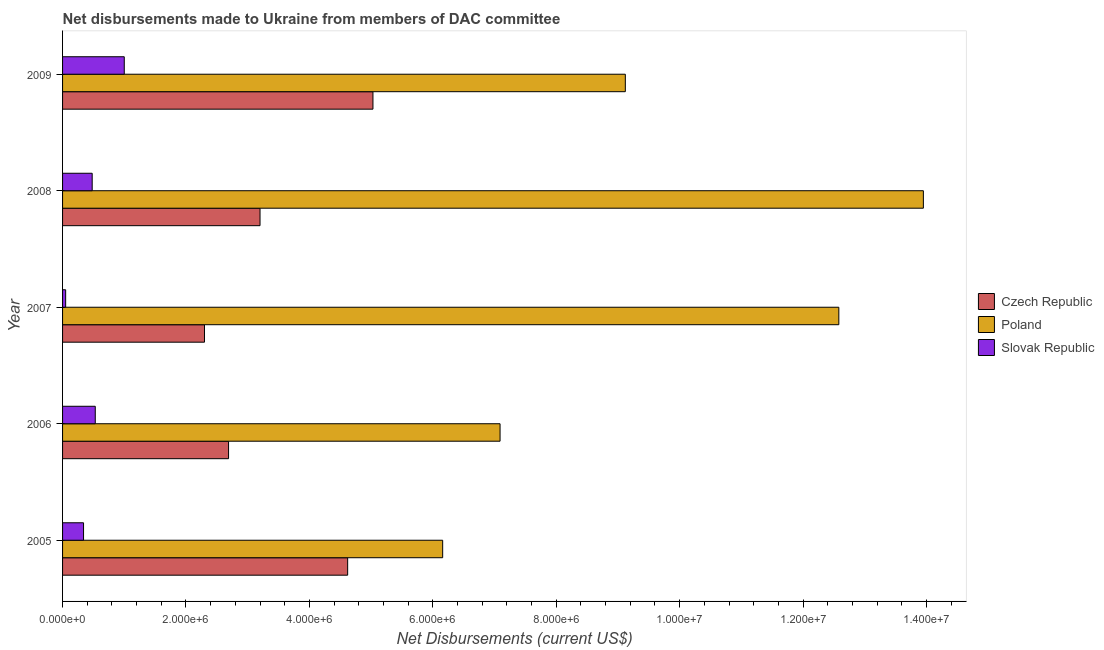Are the number of bars per tick equal to the number of legend labels?
Make the answer very short. Yes. Are the number of bars on each tick of the Y-axis equal?
Give a very brief answer. Yes. What is the label of the 5th group of bars from the top?
Your response must be concise. 2005. In how many cases, is the number of bars for a given year not equal to the number of legend labels?
Keep it short and to the point. 0. What is the net disbursements made by slovak republic in 2008?
Your response must be concise. 4.80e+05. Across all years, what is the maximum net disbursements made by slovak republic?
Offer a very short reply. 1.00e+06. Across all years, what is the minimum net disbursements made by slovak republic?
Make the answer very short. 5.00e+04. In which year was the net disbursements made by poland minimum?
Provide a short and direct response. 2005. What is the total net disbursements made by czech republic in the graph?
Provide a succinct answer. 1.78e+07. What is the difference between the net disbursements made by poland in 2005 and that in 2009?
Provide a short and direct response. -2.96e+06. What is the difference between the net disbursements made by czech republic in 2009 and the net disbursements made by poland in 2005?
Offer a terse response. -1.13e+06. What is the average net disbursements made by slovak republic per year?
Provide a short and direct response. 4.80e+05. In the year 2009, what is the difference between the net disbursements made by slovak republic and net disbursements made by czech republic?
Your answer should be very brief. -4.03e+06. In how many years, is the net disbursements made by czech republic greater than 7600000 US$?
Provide a short and direct response. 0. What is the ratio of the net disbursements made by czech republic in 2006 to that in 2009?
Ensure brevity in your answer.  0.54. Is the difference between the net disbursements made by slovak republic in 2006 and 2009 greater than the difference between the net disbursements made by poland in 2006 and 2009?
Your answer should be compact. Yes. What is the difference between the highest and the second highest net disbursements made by czech republic?
Give a very brief answer. 4.10e+05. What is the difference between the highest and the lowest net disbursements made by slovak republic?
Ensure brevity in your answer.  9.50e+05. What does the 3rd bar from the top in 2005 represents?
Your response must be concise. Czech Republic. What does the 2nd bar from the bottom in 2005 represents?
Your answer should be very brief. Poland. Are all the bars in the graph horizontal?
Ensure brevity in your answer.  Yes. How many years are there in the graph?
Your answer should be compact. 5. What is the difference between two consecutive major ticks on the X-axis?
Provide a short and direct response. 2.00e+06. Are the values on the major ticks of X-axis written in scientific E-notation?
Give a very brief answer. Yes. Does the graph contain any zero values?
Offer a terse response. No. Does the graph contain grids?
Keep it short and to the point. No. How many legend labels are there?
Provide a succinct answer. 3. How are the legend labels stacked?
Your response must be concise. Vertical. What is the title of the graph?
Make the answer very short. Net disbursements made to Ukraine from members of DAC committee. Does "Ages 20-60" appear as one of the legend labels in the graph?
Give a very brief answer. No. What is the label or title of the X-axis?
Provide a short and direct response. Net Disbursements (current US$). What is the Net Disbursements (current US$) of Czech Republic in 2005?
Offer a very short reply. 4.62e+06. What is the Net Disbursements (current US$) in Poland in 2005?
Your response must be concise. 6.16e+06. What is the Net Disbursements (current US$) of Czech Republic in 2006?
Keep it short and to the point. 2.69e+06. What is the Net Disbursements (current US$) in Poland in 2006?
Provide a succinct answer. 7.09e+06. What is the Net Disbursements (current US$) in Slovak Republic in 2006?
Make the answer very short. 5.30e+05. What is the Net Disbursements (current US$) of Czech Republic in 2007?
Provide a succinct answer. 2.30e+06. What is the Net Disbursements (current US$) of Poland in 2007?
Provide a succinct answer. 1.26e+07. What is the Net Disbursements (current US$) in Czech Republic in 2008?
Give a very brief answer. 3.20e+06. What is the Net Disbursements (current US$) of Poland in 2008?
Your response must be concise. 1.40e+07. What is the Net Disbursements (current US$) in Slovak Republic in 2008?
Provide a succinct answer. 4.80e+05. What is the Net Disbursements (current US$) of Czech Republic in 2009?
Ensure brevity in your answer.  5.03e+06. What is the Net Disbursements (current US$) in Poland in 2009?
Offer a terse response. 9.12e+06. Across all years, what is the maximum Net Disbursements (current US$) of Czech Republic?
Your answer should be compact. 5.03e+06. Across all years, what is the maximum Net Disbursements (current US$) of Poland?
Your response must be concise. 1.40e+07. Across all years, what is the maximum Net Disbursements (current US$) in Slovak Republic?
Give a very brief answer. 1.00e+06. Across all years, what is the minimum Net Disbursements (current US$) of Czech Republic?
Keep it short and to the point. 2.30e+06. Across all years, what is the minimum Net Disbursements (current US$) of Poland?
Offer a very short reply. 6.16e+06. Across all years, what is the minimum Net Disbursements (current US$) of Slovak Republic?
Ensure brevity in your answer.  5.00e+04. What is the total Net Disbursements (current US$) in Czech Republic in the graph?
Your response must be concise. 1.78e+07. What is the total Net Disbursements (current US$) in Poland in the graph?
Offer a terse response. 4.89e+07. What is the total Net Disbursements (current US$) in Slovak Republic in the graph?
Your answer should be compact. 2.40e+06. What is the difference between the Net Disbursements (current US$) of Czech Republic in 2005 and that in 2006?
Offer a very short reply. 1.93e+06. What is the difference between the Net Disbursements (current US$) of Poland in 2005 and that in 2006?
Your response must be concise. -9.30e+05. What is the difference between the Net Disbursements (current US$) in Slovak Republic in 2005 and that in 2006?
Give a very brief answer. -1.90e+05. What is the difference between the Net Disbursements (current US$) of Czech Republic in 2005 and that in 2007?
Your answer should be compact. 2.32e+06. What is the difference between the Net Disbursements (current US$) of Poland in 2005 and that in 2007?
Keep it short and to the point. -6.42e+06. What is the difference between the Net Disbursements (current US$) in Czech Republic in 2005 and that in 2008?
Ensure brevity in your answer.  1.42e+06. What is the difference between the Net Disbursements (current US$) in Poland in 2005 and that in 2008?
Ensure brevity in your answer.  -7.79e+06. What is the difference between the Net Disbursements (current US$) in Slovak Republic in 2005 and that in 2008?
Keep it short and to the point. -1.40e+05. What is the difference between the Net Disbursements (current US$) of Czech Republic in 2005 and that in 2009?
Offer a terse response. -4.10e+05. What is the difference between the Net Disbursements (current US$) of Poland in 2005 and that in 2009?
Keep it short and to the point. -2.96e+06. What is the difference between the Net Disbursements (current US$) of Slovak Republic in 2005 and that in 2009?
Your answer should be compact. -6.60e+05. What is the difference between the Net Disbursements (current US$) of Poland in 2006 and that in 2007?
Provide a succinct answer. -5.49e+06. What is the difference between the Net Disbursements (current US$) of Slovak Republic in 2006 and that in 2007?
Provide a succinct answer. 4.80e+05. What is the difference between the Net Disbursements (current US$) in Czech Republic in 2006 and that in 2008?
Ensure brevity in your answer.  -5.10e+05. What is the difference between the Net Disbursements (current US$) in Poland in 2006 and that in 2008?
Your answer should be very brief. -6.86e+06. What is the difference between the Net Disbursements (current US$) of Slovak Republic in 2006 and that in 2008?
Keep it short and to the point. 5.00e+04. What is the difference between the Net Disbursements (current US$) in Czech Republic in 2006 and that in 2009?
Make the answer very short. -2.34e+06. What is the difference between the Net Disbursements (current US$) in Poland in 2006 and that in 2009?
Your answer should be very brief. -2.03e+06. What is the difference between the Net Disbursements (current US$) in Slovak Republic in 2006 and that in 2009?
Provide a short and direct response. -4.70e+05. What is the difference between the Net Disbursements (current US$) in Czech Republic in 2007 and that in 2008?
Ensure brevity in your answer.  -9.00e+05. What is the difference between the Net Disbursements (current US$) of Poland in 2007 and that in 2008?
Provide a short and direct response. -1.37e+06. What is the difference between the Net Disbursements (current US$) in Slovak Republic in 2007 and that in 2008?
Make the answer very short. -4.30e+05. What is the difference between the Net Disbursements (current US$) of Czech Republic in 2007 and that in 2009?
Provide a short and direct response. -2.73e+06. What is the difference between the Net Disbursements (current US$) of Poland in 2007 and that in 2009?
Your response must be concise. 3.46e+06. What is the difference between the Net Disbursements (current US$) of Slovak Republic in 2007 and that in 2009?
Offer a terse response. -9.50e+05. What is the difference between the Net Disbursements (current US$) of Czech Republic in 2008 and that in 2009?
Provide a succinct answer. -1.83e+06. What is the difference between the Net Disbursements (current US$) of Poland in 2008 and that in 2009?
Offer a very short reply. 4.83e+06. What is the difference between the Net Disbursements (current US$) in Slovak Republic in 2008 and that in 2009?
Make the answer very short. -5.20e+05. What is the difference between the Net Disbursements (current US$) of Czech Republic in 2005 and the Net Disbursements (current US$) of Poland in 2006?
Provide a succinct answer. -2.47e+06. What is the difference between the Net Disbursements (current US$) of Czech Republic in 2005 and the Net Disbursements (current US$) of Slovak Republic in 2006?
Keep it short and to the point. 4.09e+06. What is the difference between the Net Disbursements (current US$) in Poland in 2005 and the Net Disbursements (current US$) in Slovak Republic in 2006?
Keep it short and to the point. 5.63e+06. What is the difference between the Net Disbursements (current US$) in Czech Republic in 2005 and the Net Disbursements (current US$) in Poland in 2007?
Ensure brevity in your answer.  -7.96e+06. What is the difference between the Net Disbursements (current US$) of Czech Republic in 2005 and the Net Disbursements (current US$) of Slovak Republic in 2007?
Your answer should be compact. 4.57e+06. What is the difference between the Net Disbursements (current US$) in Poland in 2005 and the Net Disbursements (current US$) in Slovak Republic in 2007?
Give a very brief answer. 6.11e+06. What is the difference between the Net Disbursements (current US$) of Czech Republic in 2005 and the Net Disbursements (current US$) of Poland in 2008?
Provide a succinct answer. -9.33e+06. What is the difference between the Net Disbursements (current US$) of Czech Republic in 2005 and the Net Disbursements (current US$) of Slovak Republic in 2008?
Provide a succinct answer. 4.14e+06. What is the difference between the Net Disbursements (current US$) of Poland in 2005 and the Net Disbursements (current US$) of Slovak Republic in 2008?
Provide a succinct answer. 5.68e+06. What is the difference between the Net Disbursements (current US$) of Czech Republic in 2005 and the Net Disbursements (current US$) of Poland in 2009?
Keep it short and to the point. -4.50e+06. What is the difference between the Net Disbursements (current US$) in Czech Republic in 2005 and the Net Disbursements (current US$) in Slovak Republic in 2009?
Give a very brief answer. 3.62e+06. What is the difference between the Net Disbursements (current US$) of Poland in 2005 and the Net Disbursements (current US$) of Slovak Republic in 2009?
Your response must be concise. 5.16e+06. What is the difference between the Net Disbursements (current US$) in Czech Republic in 2006 and the Net Disbursements (current US$) in Poland in 2007?
Give a very brief answer. -9.89e+06. What is the difference between the Net Disbursements (current US$) in Czech Republic in 2006 and the Net Disbursements (current US$) in Slovak Republic in 2007?
Offer a very short reply. 2.64e+06. What is the difference between the Net Disbursements (current US$) in Poland in 2006 and the Net Disbursements (current US$) in Slovak Republic in 2007?
Offer a very short reply. 7.04e+06. What is the difference between the Net Disbursements (current US$) of Czech Republic in 2006 and the Net Disbursements (current US$) of Poland in 2008?
Provide a short and direct response. -1.13e+07. What is the difference between the Net Disbursements (current US$) of Czech Republic in 2006 and the Net Disbursements (current US$) of Slovak Republic in 2008?
Ensure brevity in your answer.  2.21e+06. What is the difference between the Net Disbursements (current US$) of Poland in 2006 and the Net Disbursements (current US$) of Slovak Republic in 2008?
Provide a short and direct response. 6.61e+06. What is the difference between the Net Disbursements (current US$) in Czech Republic in 2006 and the Net Disbursements (current US$) in Poland in 2009?
Keep it short and to the point. -6.43e+06. What is the difference between the Net Disbursements (current US$) of Czech Republic in 2006 and the Net Disbursements (current US$) of Slovak Republic in 2009?
Your answer should be very brief. 1.69e+06. What is the difference between the Net Disbursements (current US$) of Poland in 2006 and the Net Disbursements (current US$) of Slovak Republic in 2009?
Provide a short and direct response. 6.09e+06. What is the difference between the Net Disbursements (current US$) in Czech Republic in 2007 and the Net Disbursements (current US$) in Poland in 2008?
Offer a terse response. -1.16e+07. What is the difference between the Net Disbursements (current US$) in Czech Republic in 2007 and the Net Disbursements (current US$) in Slovak Republic in 2008?
Give a very brief answer. 1.82e+06. What is the difference between the Net Disbursements (current US$) of Poland in 2007 and the Net Disbursements (current US$) of Slovak Republic in 2008?
Offer a terse response. 1.21e+07. What is the difference between the Net Disbursements (current US$) in Czech Republic in 2007 and the Net Disbursements (current US$) in Poland in 2009?
Your response must be concise. -6.82e+06. What is the difference between the Net Disbursements (current US$) of Czech Republic in 2007 and the Net Disbursements (current US$) of Slovak Republic in 2009?
Offer a very short reply. 1.30e+06. What is the difference between the Net Disbursements (current US$) in Poland in 2007 and the Net Disbursements (current US$) in Slovak Republic in 2009?
Your answer should be compact. 1.16e+07. What is the difference between the Net Disbursements (current US$) of Czech Republic in 2008 and the Net Disbursements (current US$) of Poland in 2009?
Make the answer very short. -5.92e+06. What is the difference between the Net Disbursements (current US$) in Czech Republic in 2008 and the Net Disbursements (current US$) in Slovak Republic in 2009?
Provide a succinct answer. 2.20e+06. What is the difference between the Net Disbursements (current US$) of Poland in 2008 and the Net Disbursements (current US$) of Slovak Republic in 2009?
Offer a terse response. 1.30e+07. What is the average Net Disbursements (current US$) in Czech Republic per year?
Give a very brief answer. 3.57e+06. What is the average Net Disbursements (current US$) of Poland per year?
Your response must be concise. 9.78e+06. What is the average Net Disbursements (current US$) in Slovak Republic per year?
Make the answer very short. 4.80e+05. In the year 2005, what is the difference between the Net Disbursements (current US$) of Czech Republic and Net Disbursements (current US$) of Poland?
Offer a very short reply. -1.54e+06. In the year 2005, what is the difference between the Net Disbursements (current US$) of Czech Republic and Net Disbursements (current US$) of Slovak Republic?
Provide a short and direct response. 4.28e+06. In the year 2005, what is the difference between the Net Disbursements (current US$) in Poland and Net Disbursements (current US$) in Slovak Republic?
Keep it short and to the point. 5.82e+06. In the year 2006, what is the difference between the Net Disbursements (current US$) in Czech Republic and Net Disbursements (current US$) in Poland?
Offer a terse response. -4.40e+06. In the year 2006, what is the difference between the Net Disbursements (current US$) in Czech Republic and Net Disbursements (current US$) in Slovak Republic?
Your answer should be very brief. 2.16e+06. In the year 2006, what is the difference between the Net Disbursements (current US$) of Poland and Net Disbursements (current US$) of Slovak Republic?
Make the answer very short. 6.56e+06. In the year 2007, what is the difference between the Net Disbursements (current US$) in Czech Republic and Net Disbursements (current US$) in Poland?
Provide a succinct answer. -1.03e+07. In the year 2007, what is the difference between the Net Disbursements (current US$) of Czech Republic and Net Disbursements (current US$) of Slovak Republic?
Offer a very short reply. 2.25e+06. In the year 2007, what is the difference between the Net Disbursements (current US$) in Poland and Net Disbursements (current US$) in Slovak Republic?
Your answer should be compact. 1.25e+07. In the year 2008, what is the difference between the Net Disbursements (current US$) of Czech Republic and Net Disbursements (current US$) of Poland?
Offer a very short reply. -1.08e+07. In the year 2008, what is the difference between the Net Disbursements (current US$) of Czech Republic and Net Disbursements (current US$) of Slovak Republic?
Provide a short and direct response. 2.72e+06. In the year 2008, what is the difference between the Net Disbursements (current US$) in Poland and Net Disbursements (current US$) in Slovak Republic?
Provide a succinct answer. 1.35e+07. In the year 2009, what is the difference between the Net Disbursements (current US$) of Czech Republic and Net Disbursements (current US$) of Poland?
Give a very brief answer. -4.09e+06. In the year 2009, what is the difference between the Net Disbursements (current US$) of Czech Republic and Net Disbursements (current US$) of Slovak Republic?
Offer a terse response. 4.03e+06. In the year 2009, what is the difference between the Net Disbursements (current US$) in Poland and Net Disbursements (current US$) in Slovak Republic?
Offer a terse response. 8.12e+06. What is the ratio of the Net Disbursements (current US$) of Czech Republic in 2005 to that in 2006?
Provide a succinct answer. 1.72. What is the ratio of the Net Disbursements (current US$) of Poland in 2005 to that in 2006?
Your answer should be very brief. 0.87. What is the ratio of the Net Disbursements (current US$) of Slovak Republic in 2005 to that in 2006?
Make the answer very short. 0.64. What is the ratio of the Net Disbursements (current US$) in Czech Republic in 2005 to that in 2007?
Offer a very short reply. 2.01. What is the ratio of the Net Disbursements (current US$) of Poland in 2005 to that in 2007?
Make the answer very short. 0.49. What is the ratio of the Net Disbursements (current US$) of Czech Republic in 2005 to that in 2008?
Your answer should be very brief. 1.44. What is the ratio of the Net Disbursements (current US$) in Poland in 2005 to that in 2008?
Ensure brevity in your answer.  0.44. What is the ratio of the Net Disbursements (current US$) in Slovak Republic in 2005 to that in 2008?
Offer a very short reply. 0.71. What is the ratio of the Net Disbursements (current US$) of Czech Republic in 2005 to that in 2009?
Offer a terse response. 0.92. What is the ratio of the Net Disbursements (current US$) of Poland in 2005 to that in 2009?
Give a very brief answer. 0.68. What is the ratio of the Net Disbursements (current US$) of Slovak Republic in 2005 to that in 2009?
Keep it short and to the point. 0.34. What is the ratio of the Net Disbursements (current US$) of Czech Republic in 2006 to that in 2007?
Your response must be concise. 1.17. What is the ratio of the Net Disbursements (current US$) of Poland in 2006 to that in 2007?
Your answer should be compact. 0.56. What is the ratio of the Net Disbursements (current US$) of Slovak Republic in 2006 to that in 2007?
Provide a succinct answer. 10.6. What is the ratio of the Net Disbursements (current US$) in Czech Republic in 2006 to that in 2008?
Make the answer very short. 0.84. What is the ratio of the Net Disbursements (current US$) in Poland in 2006 to that in 2008?
Provide a succinct answer. 0.51. What is the ratio of the Net Disbursements (current US$) of Slovak Republic in 2006 to that in 2008?
Keep it short and to the point. 1.1. What is the ratio of the Net Disbursements (current US$) of Czech Republic in 2006 to that in 2009?
Give a very brief answer. 0.53. What is the ratio of the Net Disbursements (current US$) in Poland in 2006 to that in 2009?
Your answer should be compact. 0.78. What is the ratio of the Net Disbursements (current US$) in Slovak Republic in 2006 to that in 2009?
Give a very brief answer. 0.53. What is the ratio of the Net Disbursements (current US$) in Czech Republic in 2007 to that in 2008?
Provide a succinct answer. 0.72. What is the ratio of the Net Disbursements (current US$) of Poland in 2007 to that in 2008?
Ensure brevity in your answer.  0.9. What is the ratio of the Net Disbursements (current US$) in Slovak Republic in 2007 to that in 2008?
Provide a succinct answer. 0.1. What is the ratio of the Net Disbursements (current US$) in Czech Republic in 2007 to that in 2009?
Your answer should be very brief. 0.46. What is the ratio of the Net Disbursements (current US$) in Poland in 2007 to that in 2009?
Provide a short and direct response. 1.38. What is the ratio of the Net Disbursements (current US$) in Czech Republic in 2008 to that in 2009?
Your response must be concise. 0.64. What is the ratio of the Net Disbursements (current US$) in Poland in 2008 to that in 2009?
Keep it short and to the point. 1.53. What is the ratio of the Net Disbursements (current US$) in Slovak Republic in 2008 to that in 2009?
Give a very brief answer. 0.48. What is the difference between the highest and the second highest Net Disbursements (current US$) of Czech Republic?
Keep it short and to the point. 4.10e+05. What is the difference between the highest and the second highest Net Disbursements (current US$) of Poland?
Your response must be concise. 1.37e+06. What is the difference between the highest and the lowest Net Disbursements (current US$) of Czech Republic?
Your answer should be compact. 2.73e+06. What is the difference between the highest and the lowest Net Disbursements (current US$) in Poland?
Your answer should be very brief. 7.79e+06. What is the difference between the highest and the lowest Net Disbursements (current US$) in Slovak Republic?
Ensure brevity in your answer.  9.50e+05. 